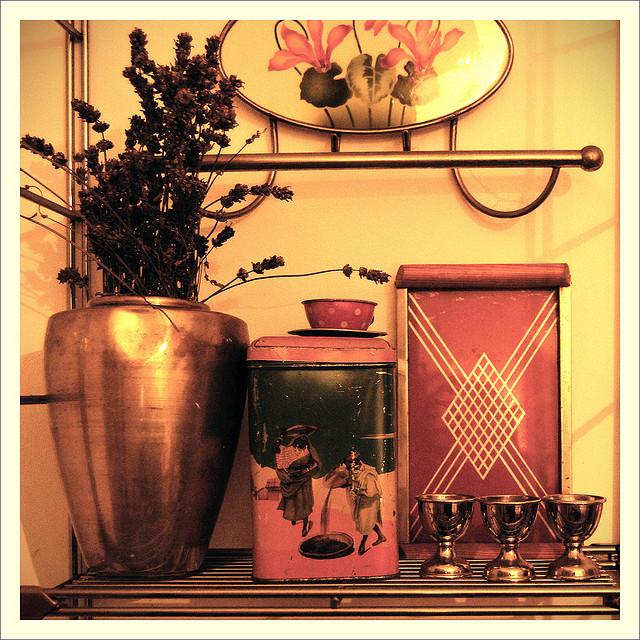What is coming out the top of the pan?
Keep it brief. Flowers. What material is the vase made of?
Answer briefly. Metal. How many objects are in the picture?
Answer briefly. 8. What are the cups made out of?
Keep it brief. Copper. What is in the vase?
Keep it brief. Flowers. 